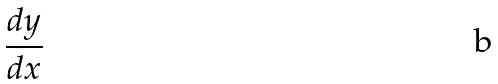Convert formula to latex. <formula><loc_0><loc_0><loc_500><loc_500>\frac { d y } { d x }</formula> 